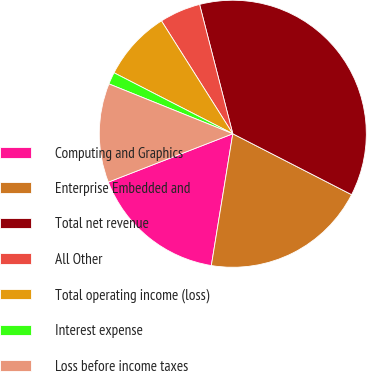Convert chart. <chart><loc_0><loc_0><loc_500><loc_500><pie_chart><fcel>Computing and Graphics<fcel>Enterprise Embedded and<fcel>Total net revenue<fcel>All Other<fcel>Total operating income (loss)<fcel>Interest expense<fcel>Loss before income taxes<nl><fcel>16.53%<fcel>20.03%<fcel>36.54%<fcel>4.97%<fcel>8.48%<fcel>1.46%<fcel>11.99%<nl></chart> 